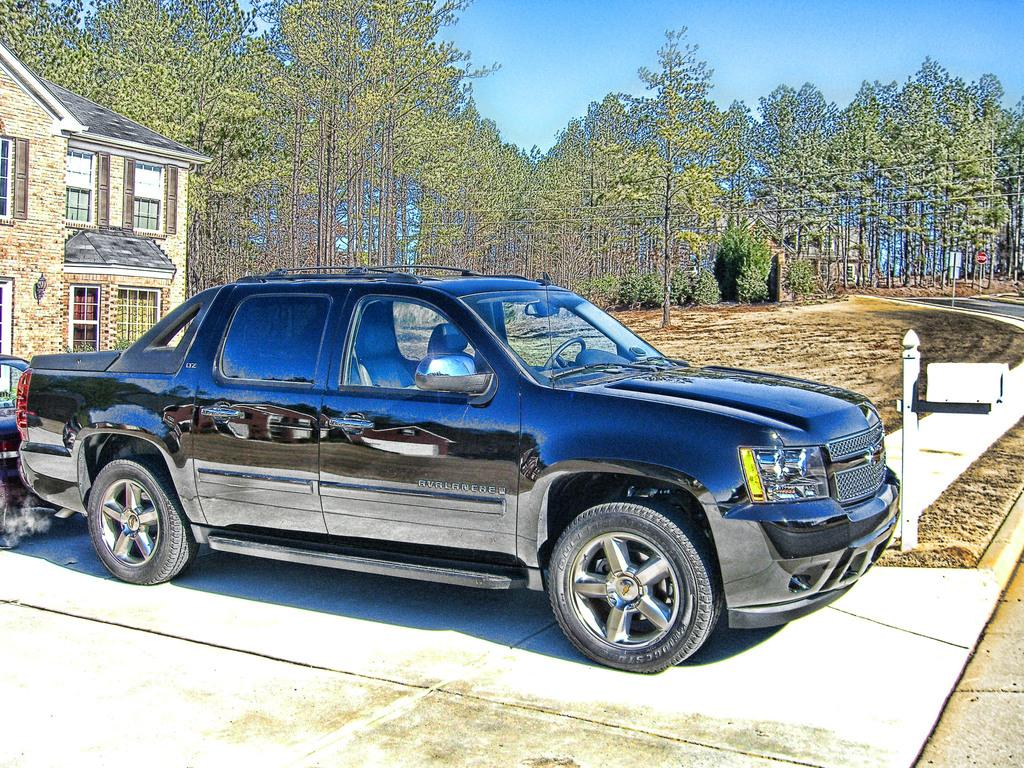What is the main subject of the image? The main subject of the image is a car. Where is the car located in relation to other objects in the image? The car is in front of a building. What can be seen beside the car? There is a rod beside the car. What is visible in the background of the image? Trees and the sky are visible in the background of the image. How many pies are stacked on top of the car in the image? There are no pies present in the image; it features a car in front of a building with a rod beside it. What type of stem can be seen growing from the car's hood in the image? There is no stem growing from the car's hood in the image. 